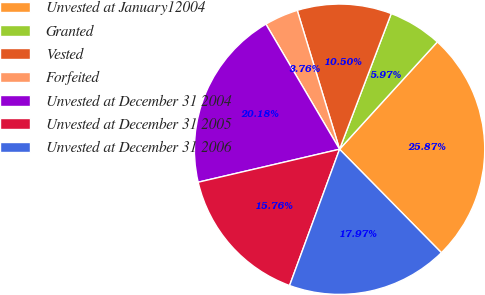Convert chart. <chart><loc_0><loc_0><loc_500><loc_500><pie_chart><fcel>Unvested at January12004<fcel>Granted<fcel>Vested<fcel>Forfeited<fcel>Unvested at December 31 2004<fcel>Unvested at December 31 2005<fcel>Unvested at December 31 2006<nl><fcel>25.87%<fcel>5.97%<fcel>10.5%<fcel>3.76%<fcel>20.18%<fcel>15.76%<fcel>17.97%<nl></chart> 